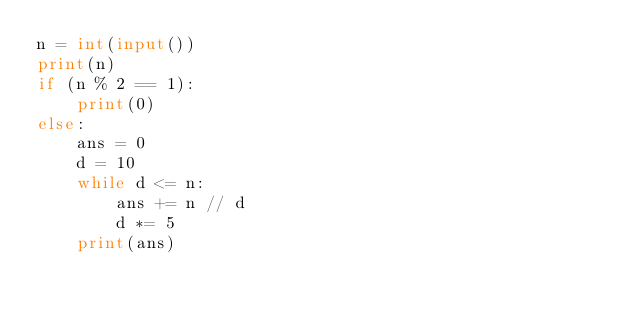<code> <loc_0><loc_0><loc_500><loc_500><_Python_>n = int(input())
print(n)
if (n % 2 == 1):
    print(0)
else:
    ans = 0
    d = 10
    while d <= n:
        ans += n // d
        d *= 5
    print(ans)
</code> 